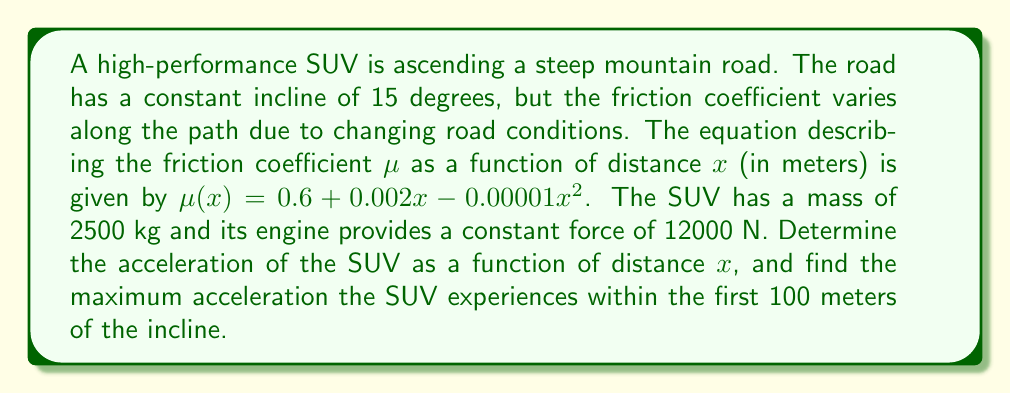Show me your answer to this math problem. Let's approach this problem step-by-step:

1) First, we need to set up the equation of motion for the SUV. We'll use Newton's Second Law, considering forces parallel to the incline:

   $$F_{net} = ma$$

2) The forces acting on the SUV are:
   - Engine force: $F_e = 12000$ N
   - Gravity component along the incline: $F_g = mg\sin\theta$
   - Friction force: $F_f = \mu(x)mg\cos\theta$

3) Substituting these into Newton's Second Law:

   $$12000 - mg\sin\theta - \mu(x)mg\cos\theta = ma(x)$$

4) We know:
   - $m = 2500$ kg
   - $g = 9.81$ m/s²
   - $\theta = 15°$
   - $\mu(x) = 0.6 + 0.002x - 0.00001x^2$

5) Substituting these values:

   $$12000 - 2500 \cdot 9.81 \cdot \sin15° - (0.6 + 0.002x - 0.00001x^2) \cdot 2500 \cdot 9.81 \cdot \cos15° = 2500a(x)$$

6) Simplifying:

   $$12000 - 6345.41 - (14534.33 + 48.45x - 0.2422x^2) = 2500a(x)$$

7) Solving for $a(x)$:

   $$a(x) = \frac{-8879.74 + 0.2422x^2 - 48.45x}{2500} = -3.55 + 0.0000969x^2 - 0.01938x$$

8) To find the maximum acceleration within the first 100 meters, we need to find the maximum value of this function in the interval [0, 100].

9) We can do this by finding where the derivative of $a(x)$ equals zero:

   $$a'(x) = 0.0001938x - 0.01938 = 0$$
   $$x = 100$$

10) Since this critical point is at the edge of our interval, we need to compare $a(0)$, $a(100)$, and $a(100)$:

    $a(0) = -3.55$
    $a(100) = -3.55 + 0.969 - 1.938 = -4.519$
    $a(100) = -3.55 + 0.969 - 1.938 = -4.519$

Therefore, the maximum acceleration occurs at $x = 0$.
Answer: The acceleration of the SUV as a function of distance is:

$$a(x) = -3.55 + 0.0000969x^2 - 0.01938x \text{ m/s²}$$

The maximum acceleration within the first 100 meters is -3.55 m/s², occurring at the start of the incline (x = 0). 